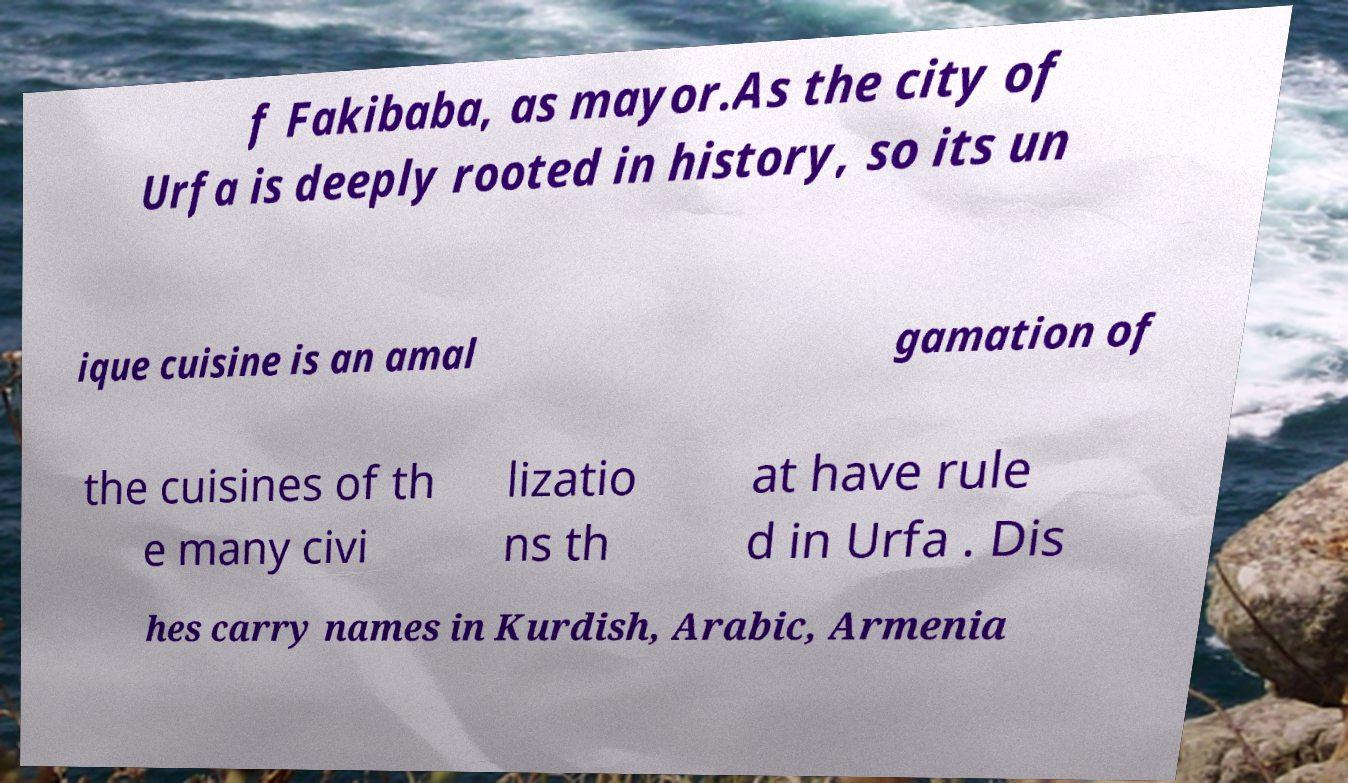There's text embedded in this image that I need extracted. Can you transcribe it verbatim? f Fakibaba, as mayor.As the city of Urfa is deeply rooted in history, so its un ique cuisine is an amal gamation of the cuisines of th e many civi lizatio ns th at have rule d in Urfa . Dis hes carry names in Kurdish, Arabic, Armenia 